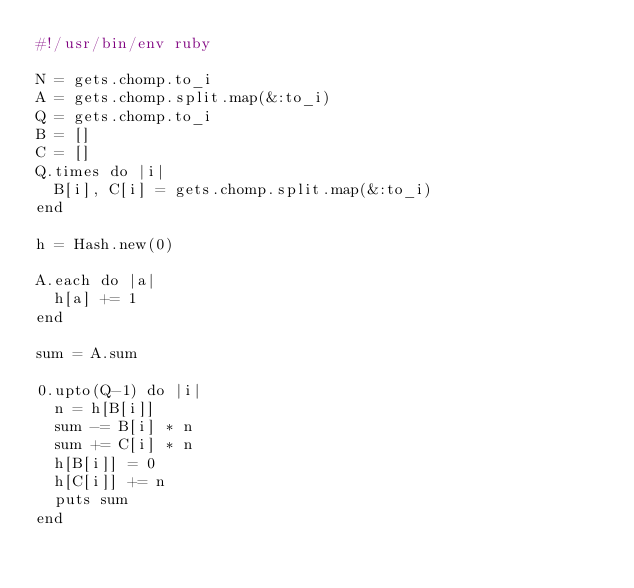<code> <loc_0><loc_0><loc_500><loc_500><_Ruby_>#!/usr/bin/env ruby

N = gets.chomp.to_i
A = gets.chomp.split.map(&:to_i)
Q = gets.chomp.to_i
B = []
C = []
Q.times do |i|
  B[i], C[i] = gets.chomp.split.map(&:to_i)
end

h = Hash.new(0)

A.each do |a|
  h[a] += 1
end

sum = A.sum

0.upto(Q-1) do |i|
  n = h[B[i]]
  sum -= B[i] * n
  sum += C[i] * n
  h[B[i]] = 0
  h[C[i]] += n
  puts sum
end
</code> 